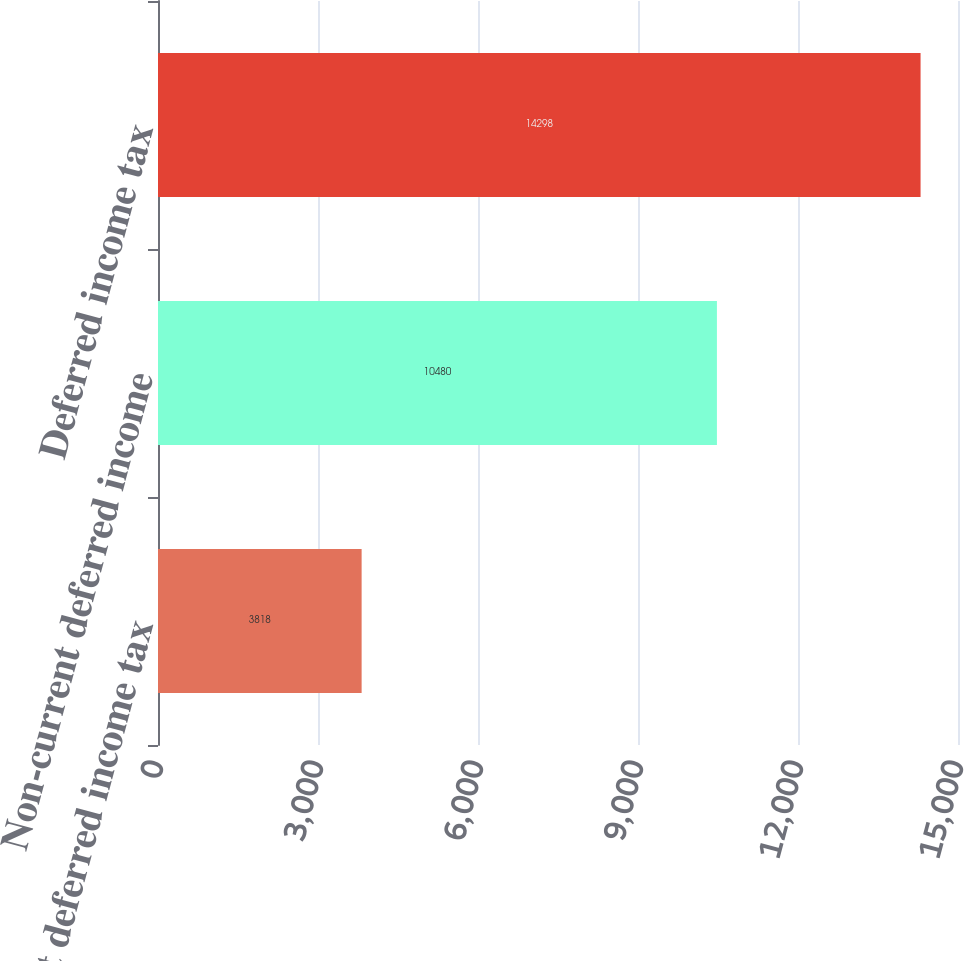Convert chart to OTSL. <chart><loc_0><loc_0><loc_500><loc_500><bar_chart><fcel>Current deferred income tax<fcel>Non-current deferred income<fcel>Deferred income tax<nl><fcel>3818<fcel>10480<fcel>14298<nl></chart> 